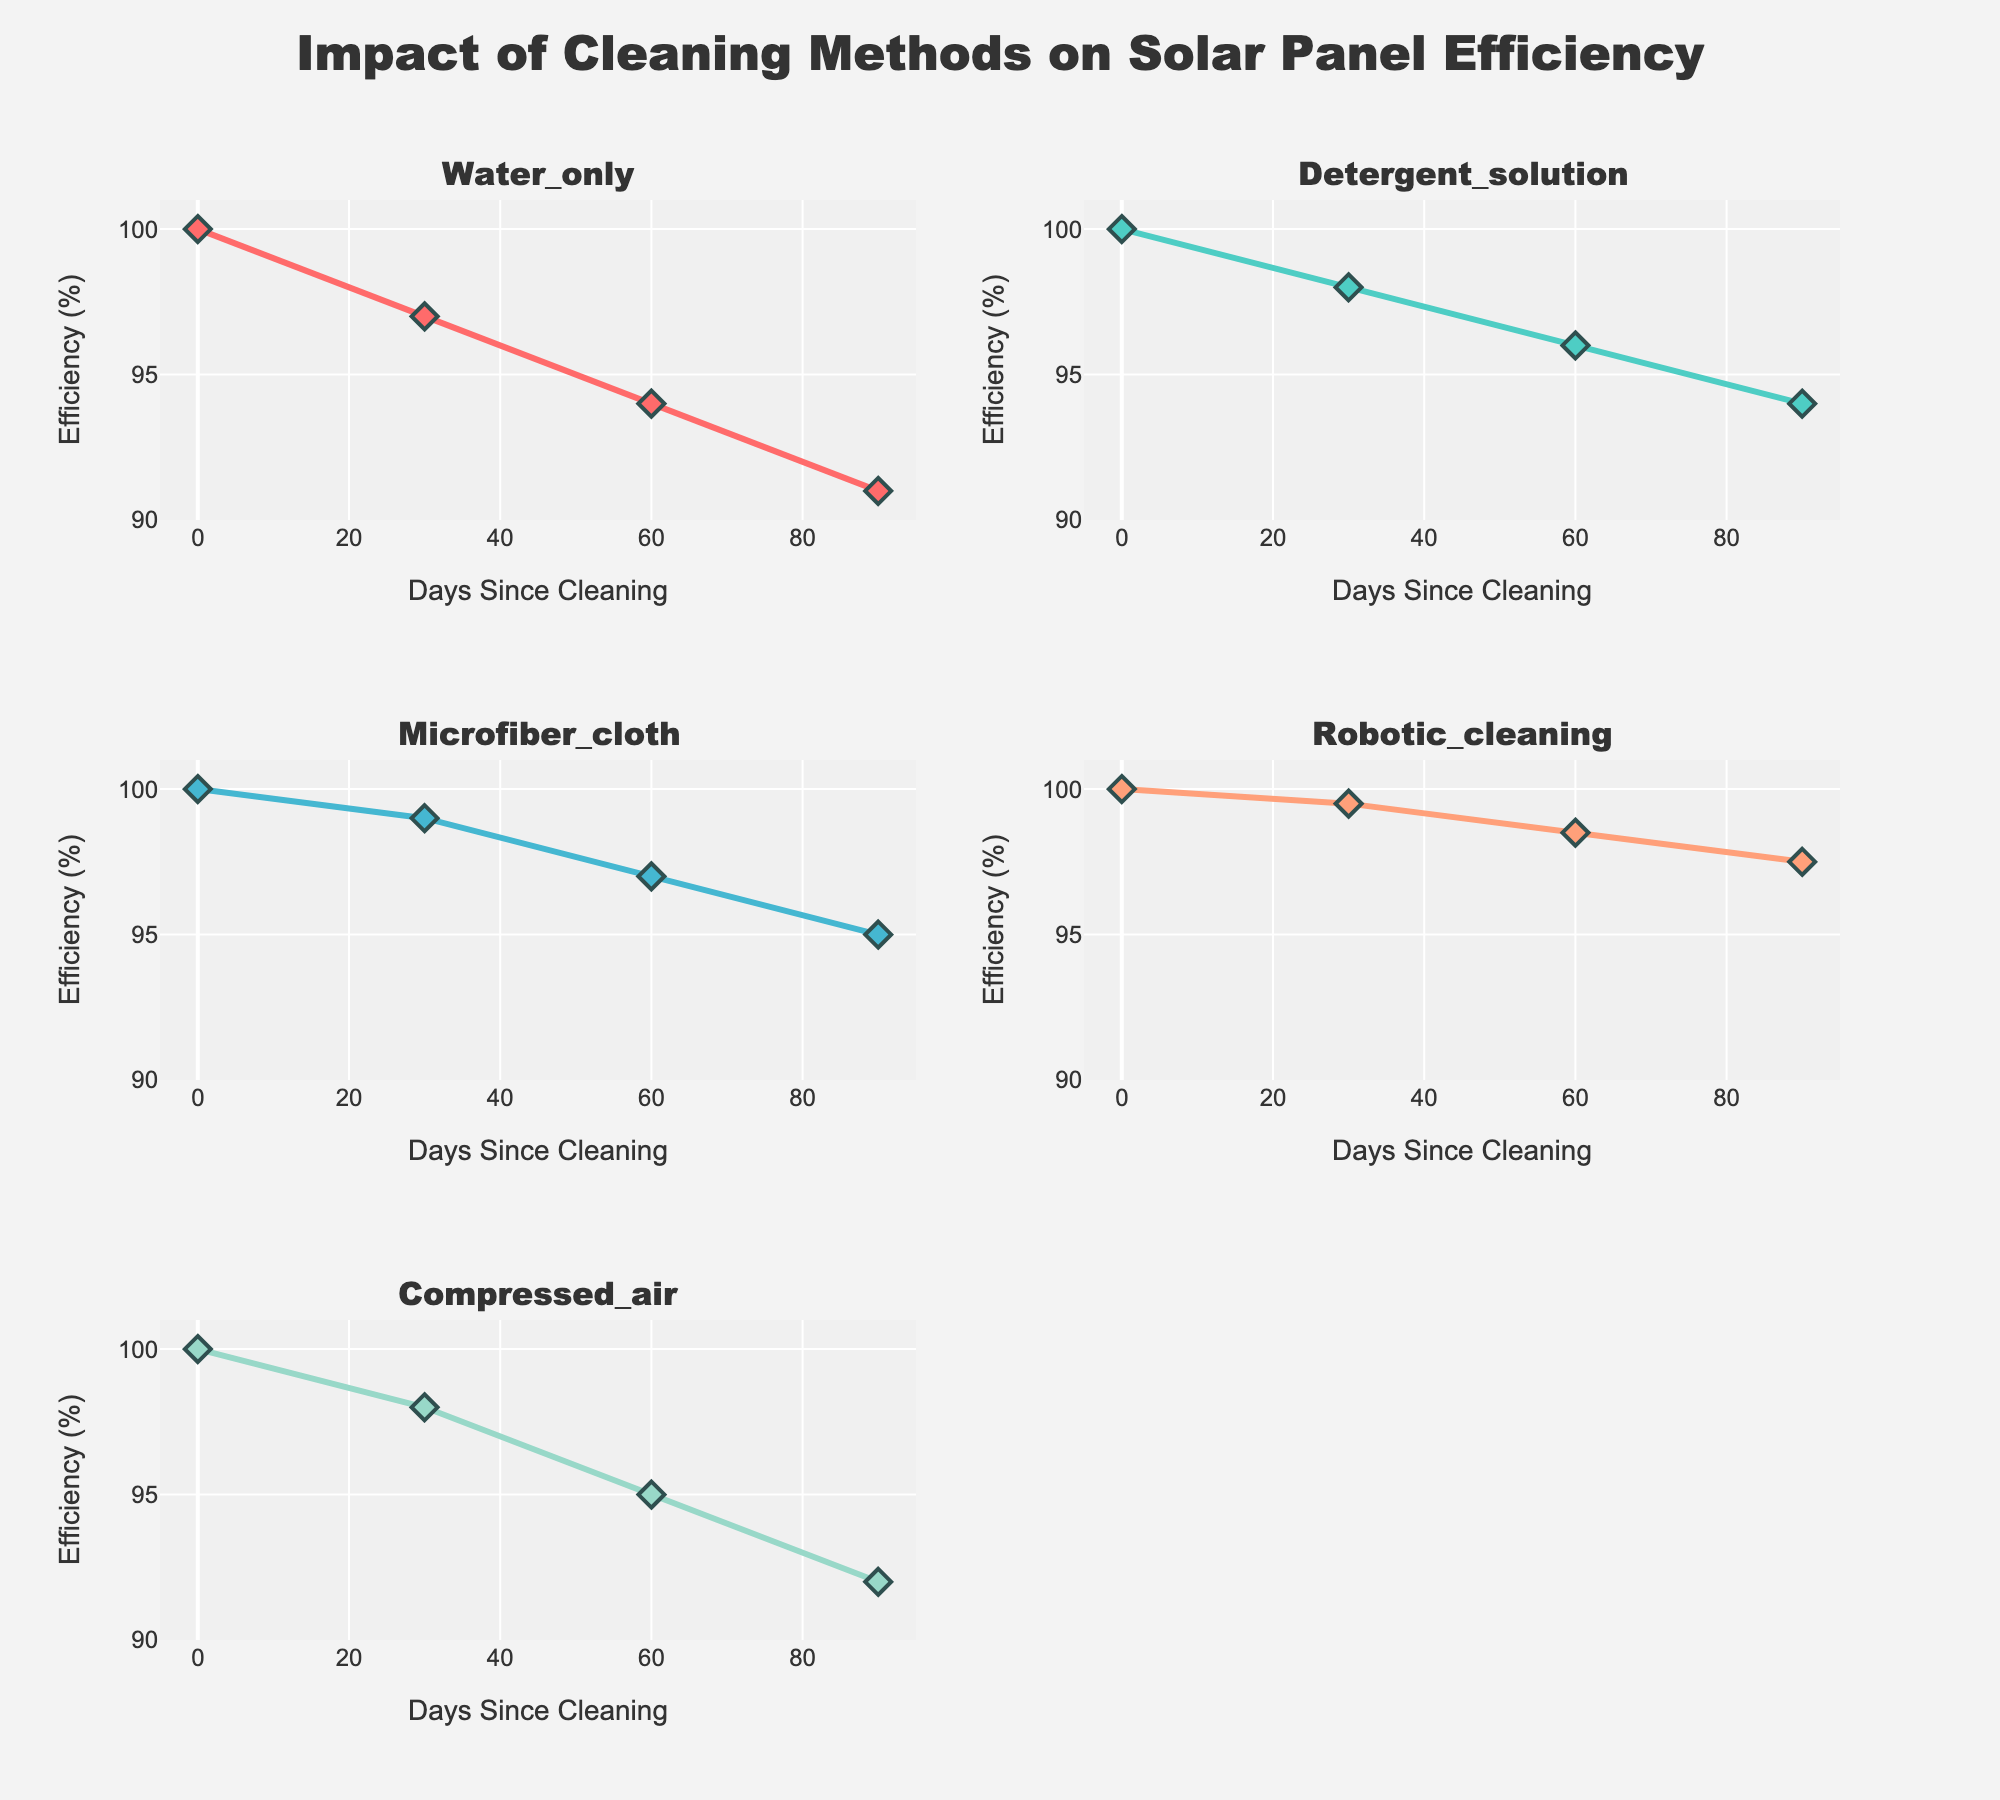What's the title of the figure? Read the title text at the top of the figure.
Answer: Prevalence of Burnout Symptoms Among Intern Doctors Which symptom has the highest prevalence in the fourth year of residency? Look at the fourth year bars for each subplot and find the one with the highest value.
Answer: Sleep Deprivation What is the difference in the prevalence of Emotional Exhaustion between the first and fifth years of residency? Identify the values of Emotional Exhaustion for the first and fifth years (68 and 50 respectively) and subtract the fifth-year value from the first-year value: 68 - 50.
Answer: 18 How does the trend of Work-Life Imbalance prevalence change from the first year to the fifth year? Observe the bars for Work-Life Imbalance from the first to fifth year; notice that there’s a gradual decline: 80, 75, 70, 65, 62. Interpret this trend as decreasing.
Answer: Decreasing Which symptom shows a consistent decrease in prevalence across all residency years? Check the bars for each symptom's subplot and look for a consistent downward trend across all years.
Answer: Depersonalization What is the average prevalence of Reduced Personal Accomplishment across all five years of residency? Sum the prevalence values for Reduced Personal Accomplishment (52, 48, 45, 42, 40) and divide by 5: (52 + 48 + 45 + 42 + 40) / 5.
Answer: 45.4 Which symptom has the smallest range (difference between the highest and lowest values) across the five years of residency? Calculate the range for each symptom, for example: Emotional Exhaustion (68-50), Depersonalization (45-33), Reduced Personal Accomplishment (52-40), Sleep Deprivation (75-58), Work-Life Imbalance (80-62), Physical Fatigue (72-57). The smallest range is found by comparing these ranges.
Answer: Depersonalization Compare the prevalence of Physical Fatigue in the first and third years of residency. Which year has a lower prevalence? Identify the values of Physical Fatigue for the first and third years (72 and 64 respectively) and compare them.
Answer: Third Year What percentage of intern doctors experienced Sleep Deprivation in the second year of residency? Locate the bar representing the second year for Sleep Deprivation and read the value.
Answer: 70% How many symptoms have their prevalence data represented by bars in the subplots? Count the number of subplots, each representing a symptom.
Answer: 6 